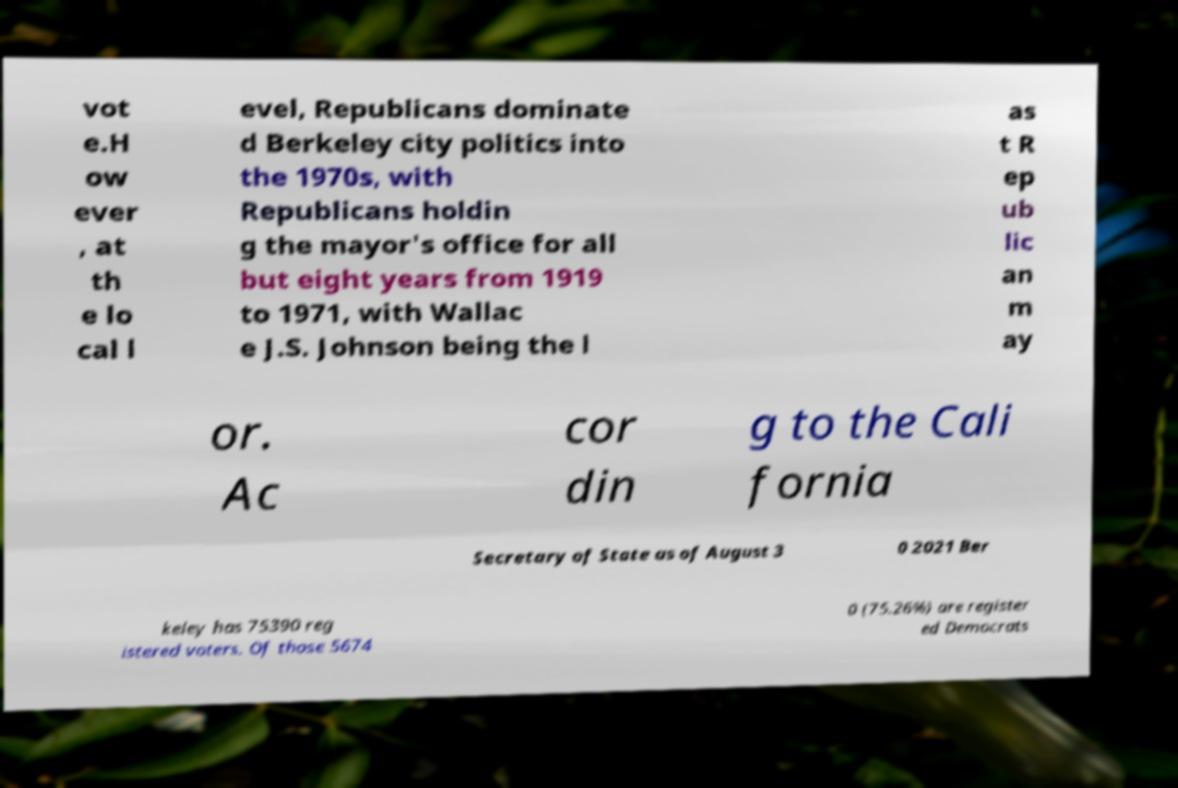What messages or text are displayed in this image? I need them in a readable, typed format. vot e.H ow ever , at th e lo cal l evel, Republicans dominate d Berkeley city politics into the 1970s, with Republicans holdin g the mayor's office for all but eight years from 1919 to 1971, with Wallac e J.S. Johnson being the l as t R ep ub lic an m ay or. Ac cor din g to the Cali fornia Secretary of State as of August 3 0 2021 Ber keley has 75390 reg istered voters. Of those 5674 0 (75.26%) are register ed Democrats 